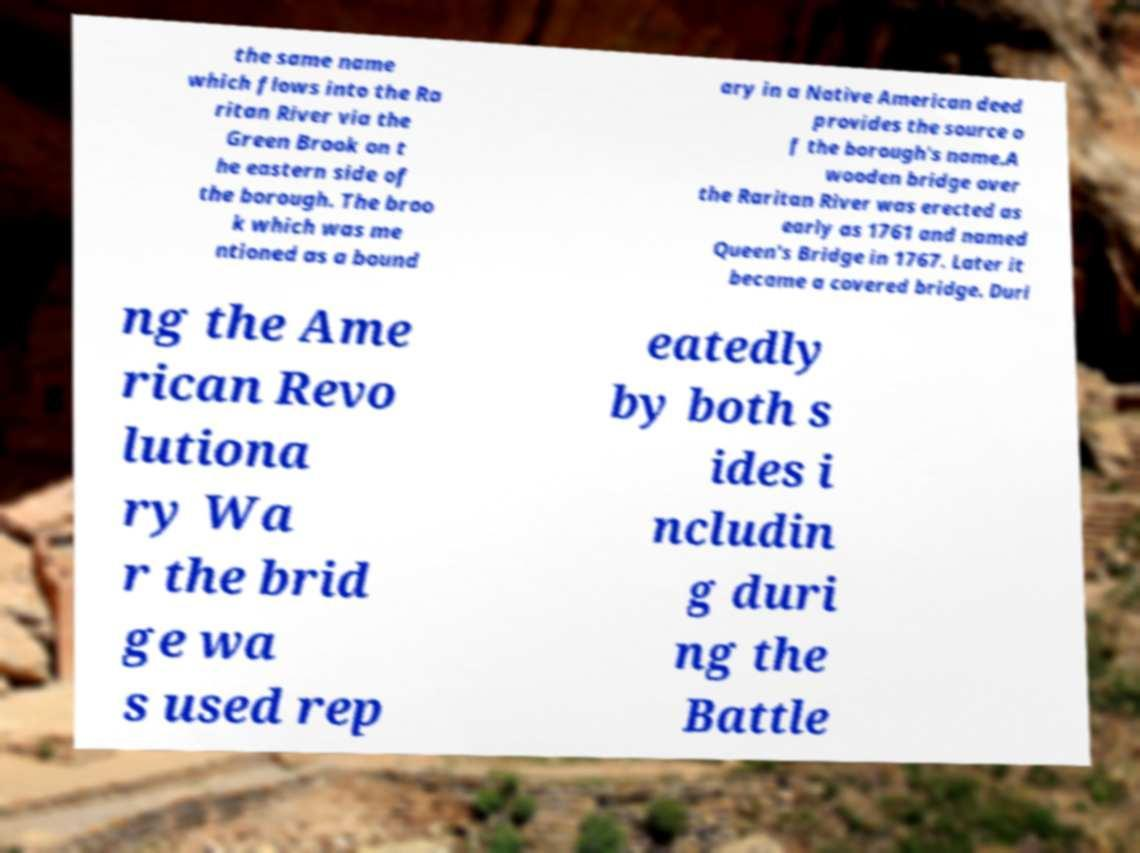For documentation purposes, I need the text within this image transcribed. Could you provide that? the same name which flows into the Ra ritan River via the Green Brook on t he eastern side of the borough. The broo k which was me ntioned as a bound ary in a Native American deed provides the source o f the borough's name.A wooden bridge over the Raritan River was erected as early as 1761 and named Queen's Bridge in 1767. Later it became a covered bridge. Duri ng the Ame rican Revo lutiona ry Wa r the brid ge wa s used rep eatedly by both s ides i ncludin g duri ng the Battle 